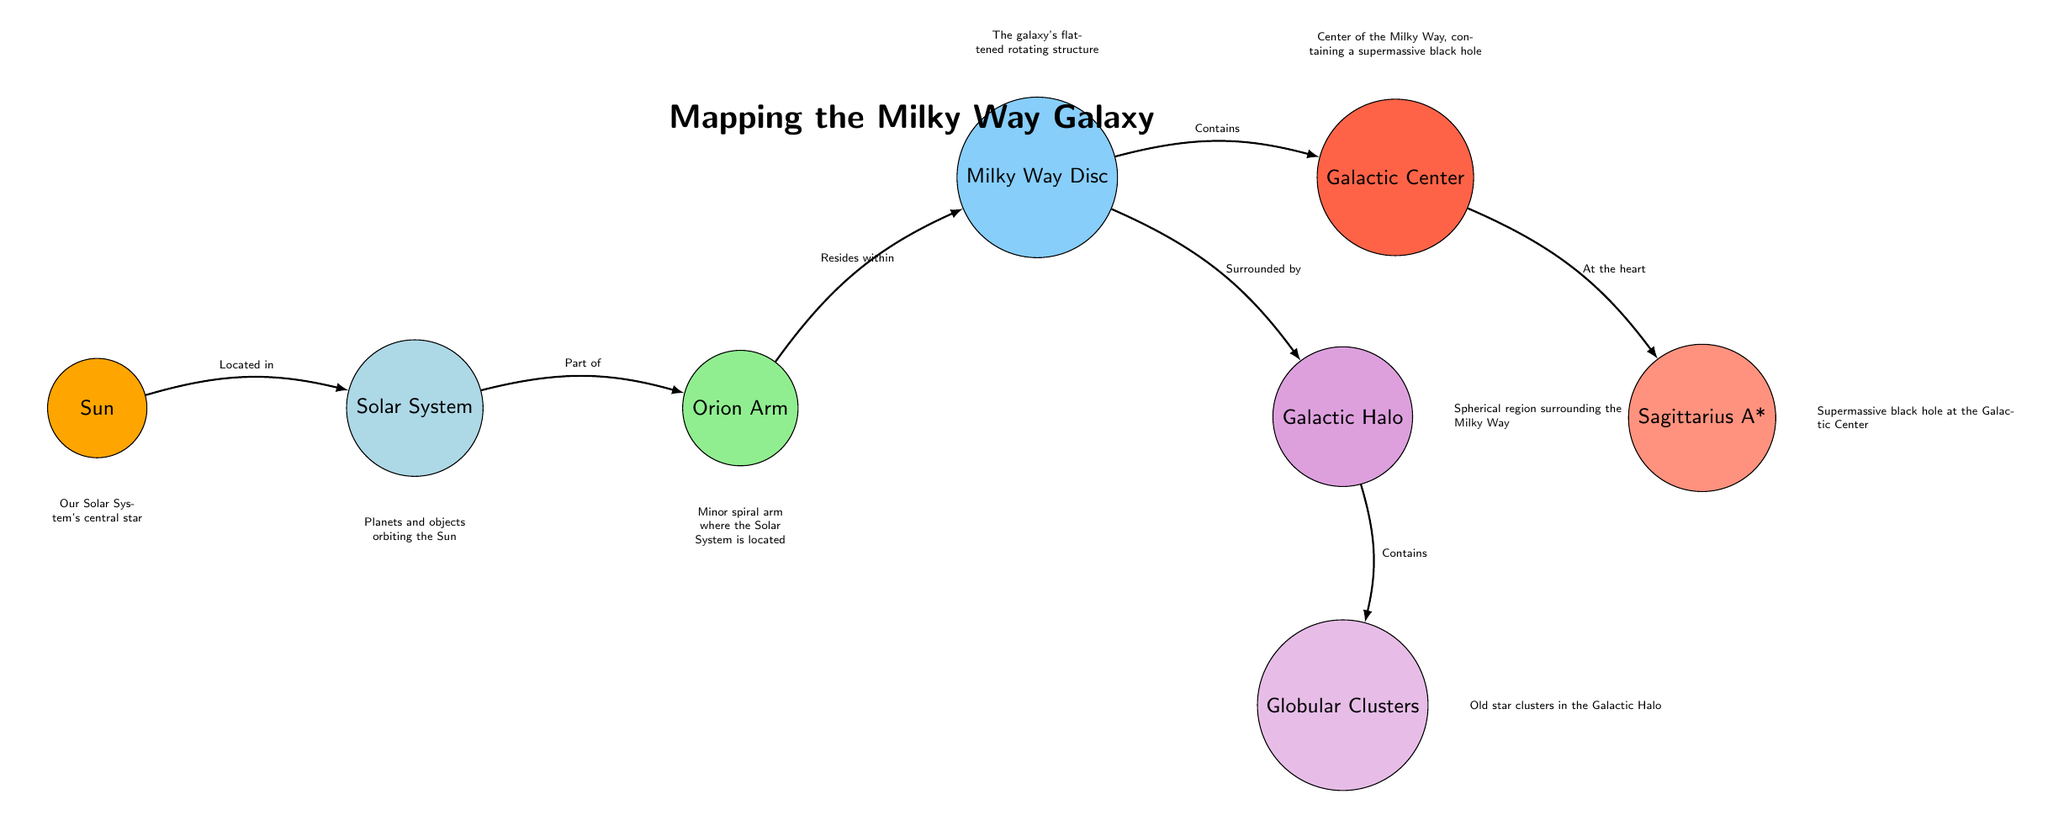What is the central star of our Solar System? In the diagram, the node titled "Sun" is specifically identified as "Our Solar System's central star," which directly answers the question about which star is at the center.
Answer: Sun What resides within the Orion Arm? The arrow from the "Orion Arm" node points to the "Milky Way Disc" node, indicating that the "Milky Way Disc" is what resides within the Orion Arm, as stated in their relationship.
Answer: Milky Way Disc How many nodes are connected to the Galactic Center? The diagram shows two directed edges leading from the "Galactic Center" node: one pointing to "Sagittarius A*" and another pointing to the "Milky Way Disc," indicating there are two nodes connected to the Galactic Center.
Answer: 2 What surrounds the Milky Way Disc? The diagram illustrates that the "Galactic Halo" node, which is depicted below the Milky Way Disc, is identified as what surrounds the Milky Way Disc based on their connecting edge.
Answer: Galactic Halo Which structure contains old star clusters? The "Globular Clusters" node is specified to contain old star clusters, as shown by the directional edge connecting the "Galactic Halo" to "Globular Clusters," confirming its function as a container of such clusters.
Answer: Globular Clusters What is located at the heart of the Milky Way? According to the diagram, the node "Sagittarius A*" is identified as being "At the heart" of the "Galactic Center," pointing to its significance in the center of the galaxy.
Answer: Sagittarius A* Which node is part of the Solar System? The "Solar System" node is directly connected to the "Sun" node with the label "Part of," indicating that the Sun is a component of the Solar System structure.
Answer: Solar System What type of structure is the Milky Way? The "Milky Way Disc" node is explicitly described in the diagram as "The galaxy's flattened rotating structure," which provides the information needed to answer the question about the type of structure it represents.
Answer: Disc Where do the old star clusters reside? The arrow leading from the "Galactic Halo" node to "Globular Clusters" indicates that old star clusters are contained within the Galactic Halo, detailing their spatial relationship in the diagram.
Answer: Galactic Halo 